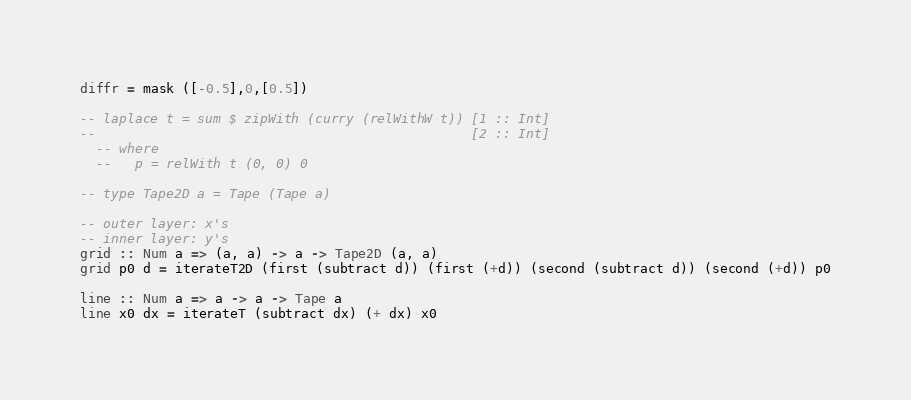<code> <loc_0><loc_0><loc_500><loc_500><_Haskell_>diffr = mask ([-0.5],0,[0.5])

-- laplace t = sum $ zipWith (curry (relWithW t)) [1 :: Int]
--                                                [2 :: Int]
  -- where
  --   p = relWith t (0, 0) 0

-- type Tape2D a = Tape (Tape a)

-- outer layer: x's
-- inner layer: y's
grid :: Num a => (a, a) -> a -> Tape2D (a, a)
grid p0 d = iterateT2D (first (subtract d)) (first (+d)) (second (subtract d)) (second (+d)) p0

line :: Num a => a -> a -> Tape a
line x0 dx = iterateT (subtract dx) (+ dx) x0

</code> 